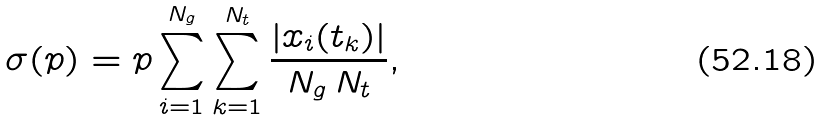<formula> <loc_0><loc_0><loc_500><loc_500>\sigma ( p ) = p \sum _ { i = 1 } ^ { N _ { g } } \sum _ { k = 1 } ^ { N _ { t } } \frac { | x _ { i } ( t _ { k } ) | } { N _ { g } \, N _ { t } } ,</formula> 